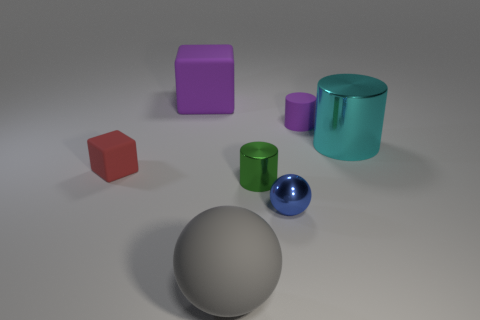What shape is the gray matte object?
Offer a terse response. Sphere. How many large purple objects have the same shape as the large gray matte thing?
Ensure brevity in your answer.  0. What number of large rubber objects are in front of the large purple block and left of the gray ball?
Make the answer very short. 0. The big matte block is what color?
Provide a short and direct response. Purple. Are there any green objects made of the same material as the blue object?
Ensure brevity in your answer.  Yes. There is a large gray object that is in front of the tiny matte object behind the tiny red rubber thing; is there a big matte object that is left of it?
Keep it short and to the point. Yes. Are there any large gray rubber things right of the small purple thing?
Your answer should be very brief. No. Are there any big things that have the same color as the tiny matte cylinder?
Keep it short and to the point. Yes. How many large objects are either red rubber things or shiny spheres?
Provide a short and direct response. 0. Is the material of the large object left of the big gray rubber object the same as the large sphere?
Offer a terse response. Yes. 